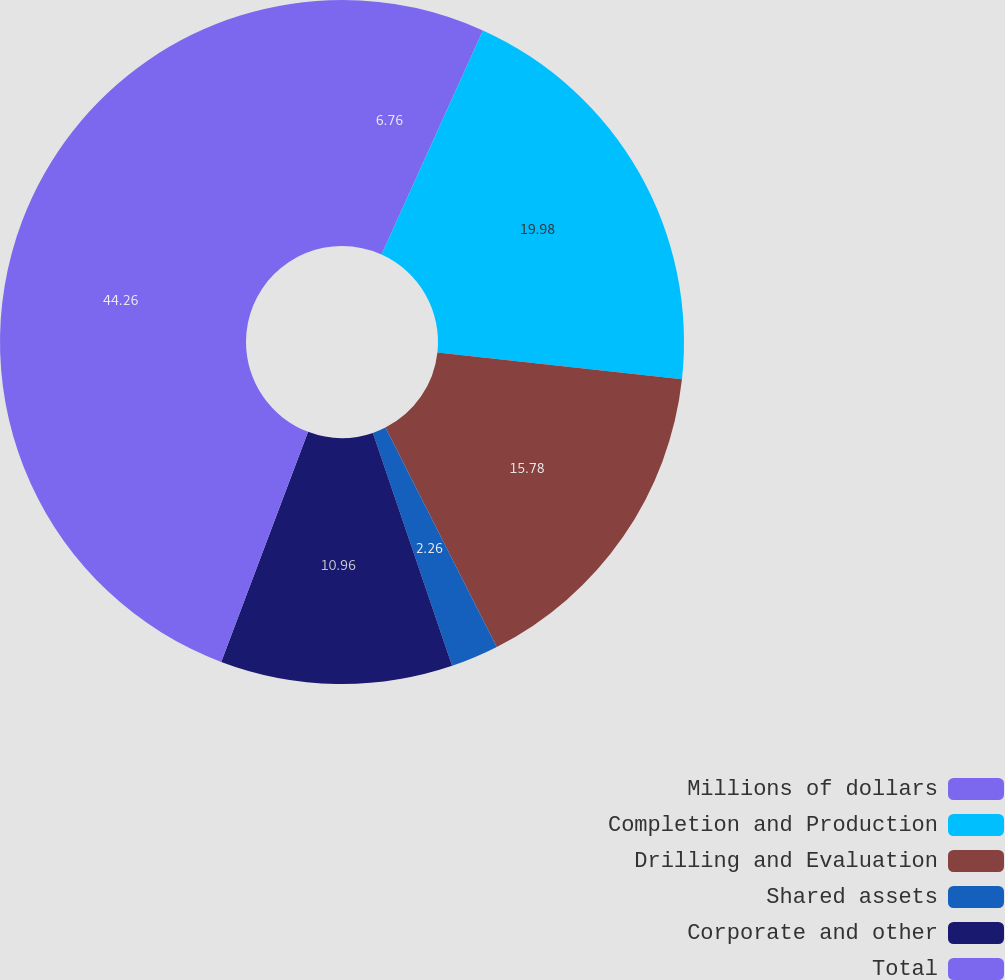Convert chart to OTSL. <chart><loc_0><loc_0><loc_500><loc_500><pie_chart><fcel>Millions of dollars<fcel>Completion and Production<fcel>Drilling and Evaluation<fcel>Shared assets<fcel>Corporate and other<fcel>Total<nl><fcel>6.76%<fcel>19.98%<fcel>15.78%<fcel>2.26%<fcel>10.96%<fcel>44.25%<nl></chart> 